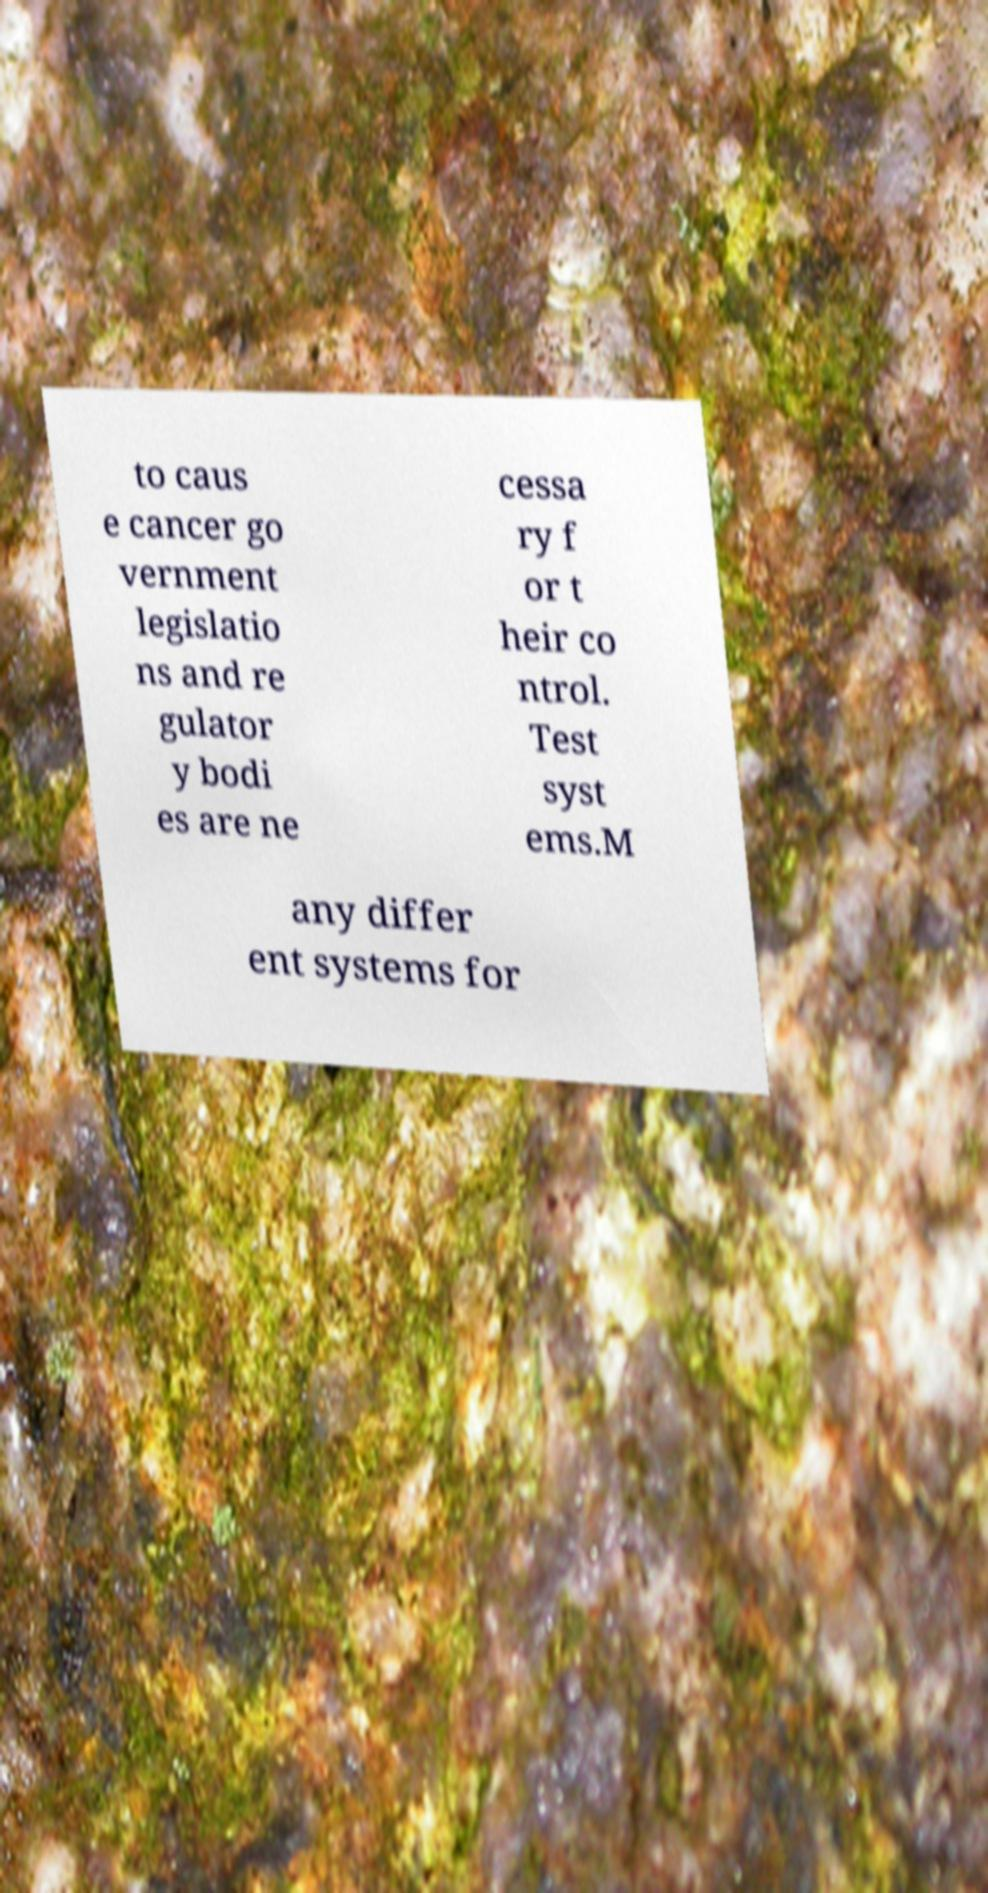Can you accurately transcribe the text from the provided image for me? to caus e cancer go vernment legislatio ns and re gulator y bodi es are ne cessa ry f or t heir co ntrol. Test syst ems.M any differ ent systems for 